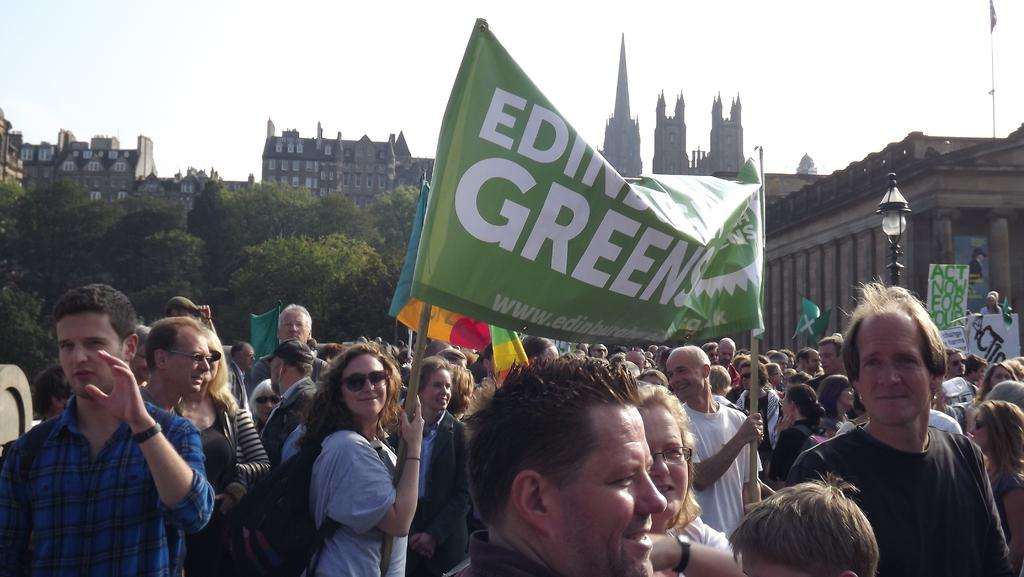What are the people in the image doing? The people in the image are standing in the center. What are two of the people holding? Two persons are holding a banner. What can be seen in the background of the image? There are trees and buildings in the background of the image. How many jellyfish are swimming in the background of the image? There are no jellyfish present in the image; it features people standing and holding a banner, with trees and buildings in the background. 